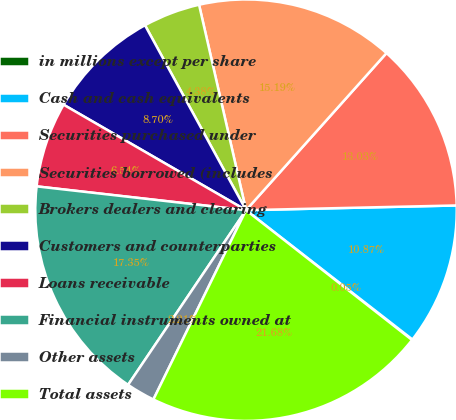Convert chart. <chart><loc_0><loc_0><loc_500><loc_500><pie_chart><fcel>in millions except per share<fcel>Cash and cash equivalents<fcel>Securities purchased under<fcel>Securities borrowed (includes<fcel>Brokers dealers and clearing<fcel>Customers and counterparties<fcel>Loans receivable<fcel>Financial instruments owned at<fcel>Other assets<fcel>Total assets<nl><fcel>0.05%<fcel>10.87%<fcel>13.03%<fcel>15.19%<fcel>4.38%<fcel>8.7%<fcel>6.54%<fcel>17.35%<fcel>2.21%<fcel>21.68%<nl></chart> 